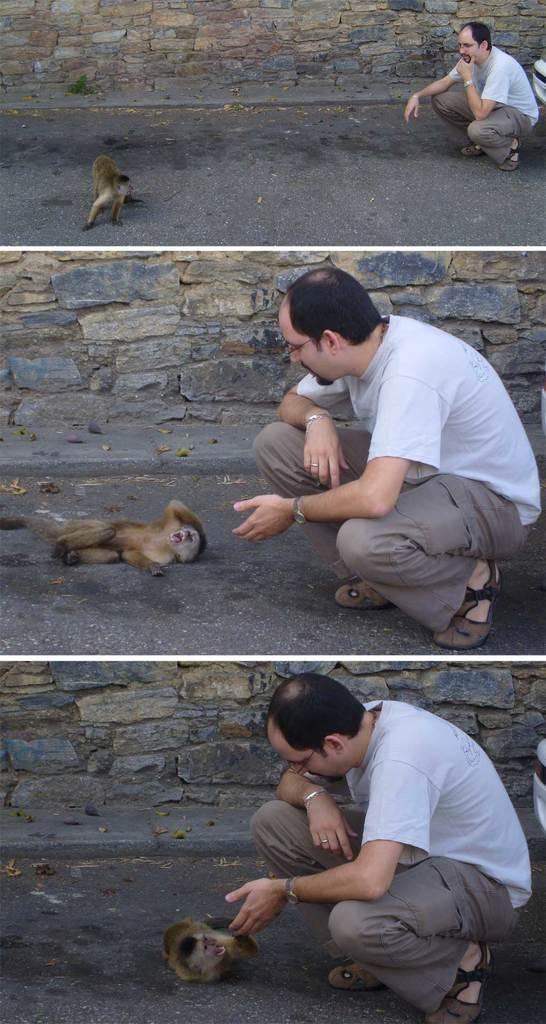Please provide a concise description of this image. This is a collage picture. In this image we can see collage images of monkey and person. 